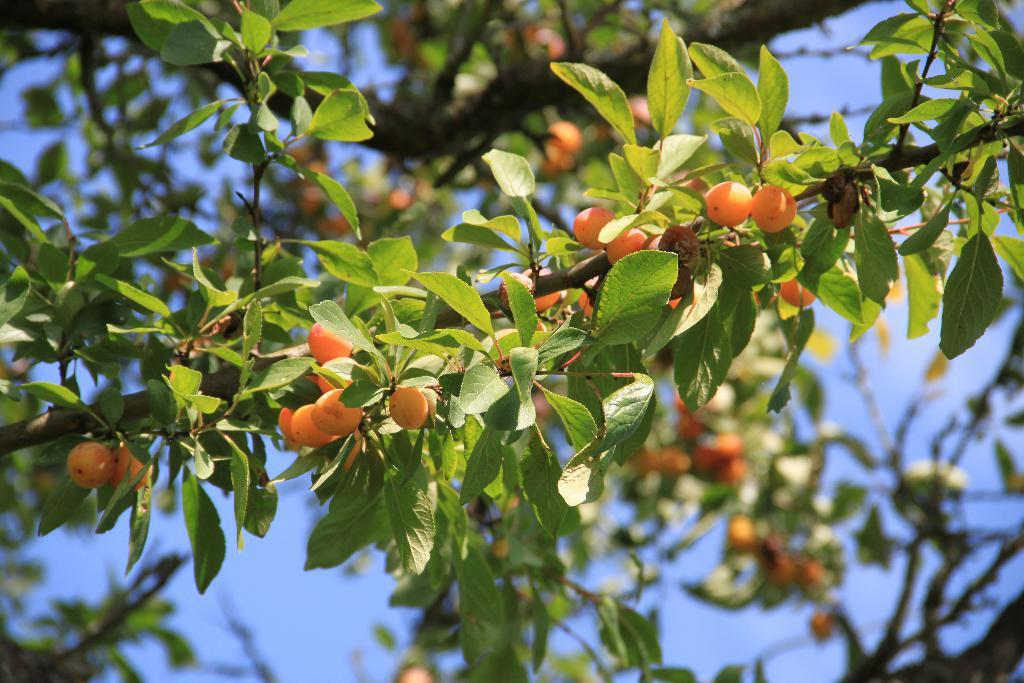What type of objects can be seen on the tree in the image? There are fruits on the tree in the image. What else can be seen on the tree besides the fruits? There are many leaves visible in the image. What is visible in the background of the image? The sky is visible in the background of the image. Can you tell me how many minutes it takes for the woman to finish sewing the quilt in the image? There is no woman or quilt present in the image, so it is not possible to answer that question. 